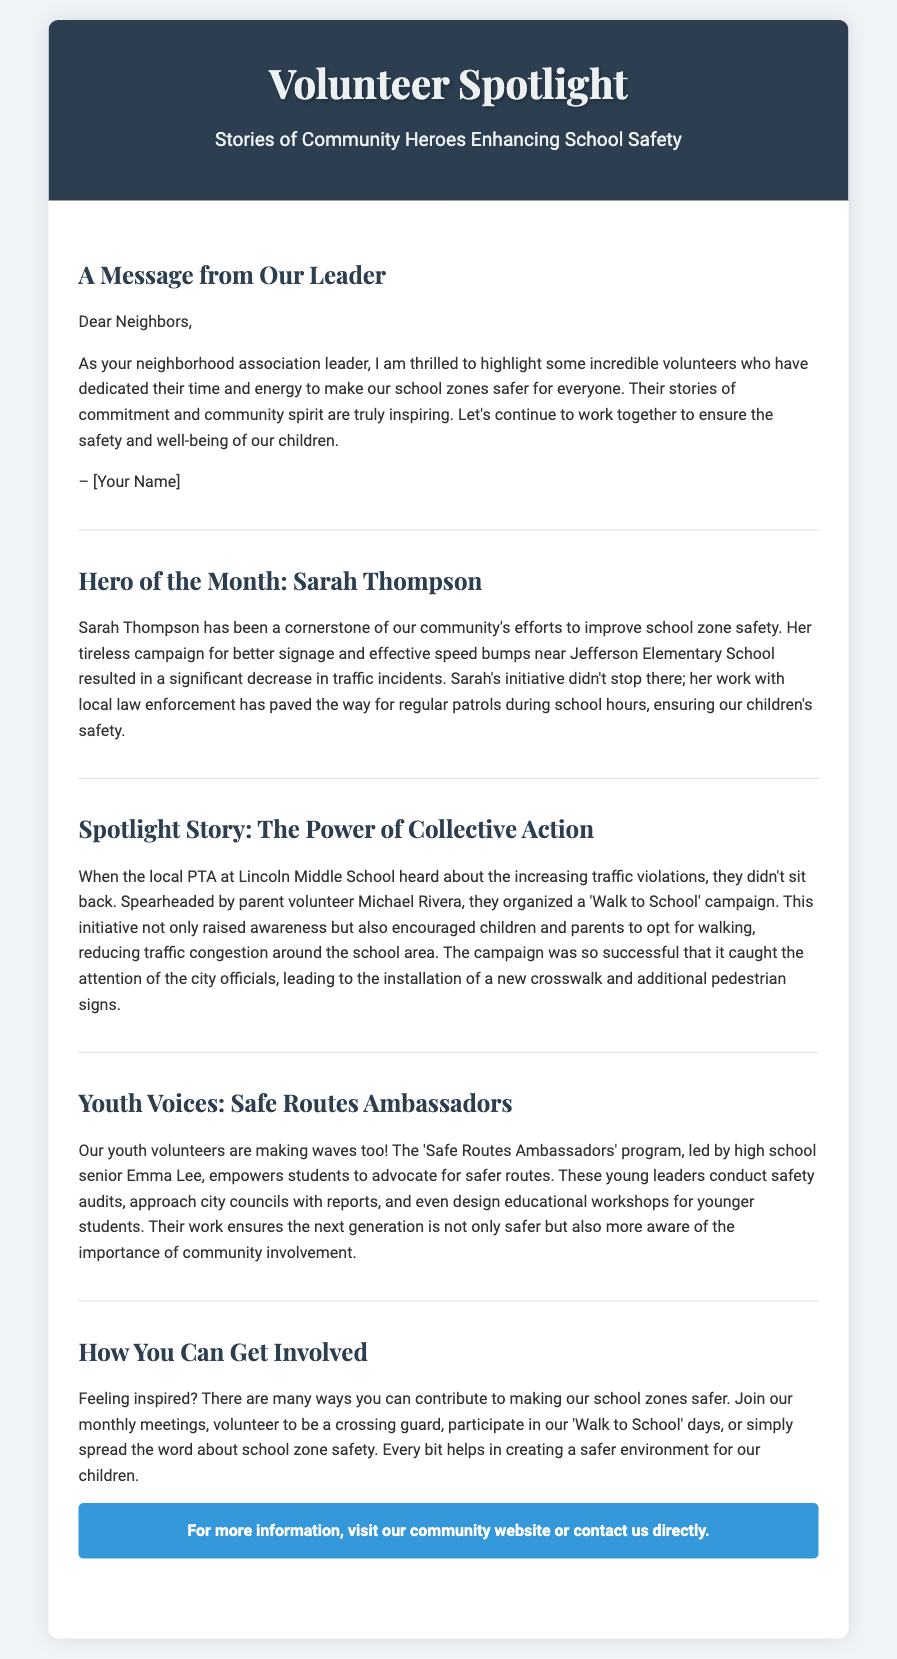What is the title of the playbill? The title of the playbill is prominently displayed as "Volunteer Spotlight: Stories of Community Heroes Enhancing School Safety".
Answer: Volunteer Spotlight: Stories of Community Heroes Enhancing School Safety Who is the Hero of the Month? The Hero of the Month is specifically named in the section as Sarah Thompson.
Answer: Sarah Thompson What initiative did Michael Rivera organize? The initiative organized by Michael Rivera is detailed as the 'Walk to School' campaign that encouraged walking to school.
Answer: Walk to School Which school is mentioned related to traffic incidents? The school involved in addressing traffic incidents through improved safety measures is Jefferson Elementary School.
Answer: Jefferson Elementary School Who leads the Safe Routes Ambassadors program? The Safe Routes Ambassadors program is led by high school senior Emma Lee, as noted in the youth voices section.
Answer: Emma Lee What can residents do to contribute to school zone safety? The document lists multiple ways residents can contribute, including joining meetings, being a crossing guard, and promoting awareness.
Answer: Join meetings, be a crossing guard, spread awareness What was the result of the 'Walk to School' campaign? The result of the campaign included the installation of a new crosswalk and additional pedestrian signs due to its success.
Answer: New crosswalk and additional pedestrian signs What message does the neighborhood association leader convey? The leader conveys a message of inspiration and community spirit regarding the efforts to enhance school safety.
Answer: Inspire community spirit How does the playbill highlight community involvement? The playbill highlights community involvement by sharing stories of volunteers and encouraging others to participate in safety initiatives.
Answer: Sharing stories of volunteers 